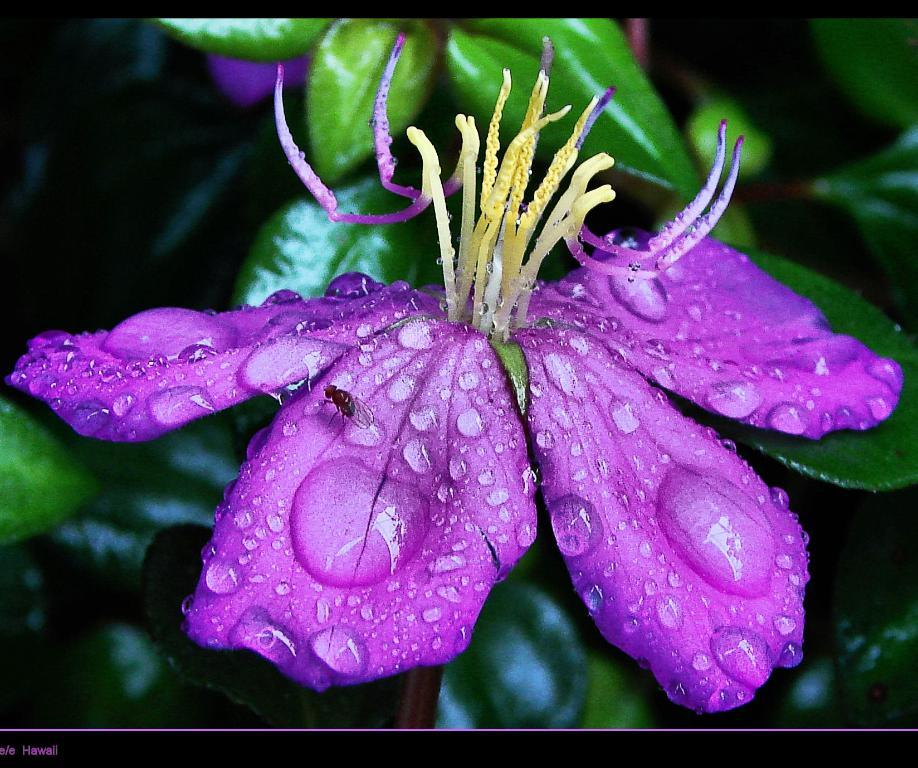What type of plant can be seen in the picture? There is a flower in the picture. What color are the leaves of the plant? There are green leaves in the picture. Can you describe any other living organisms present in the image? There is an insect on the petal of the flower. What type of money can be seen in the picture? There is no money present in the image; it features a flower with green leaves and an insect on the petal. 